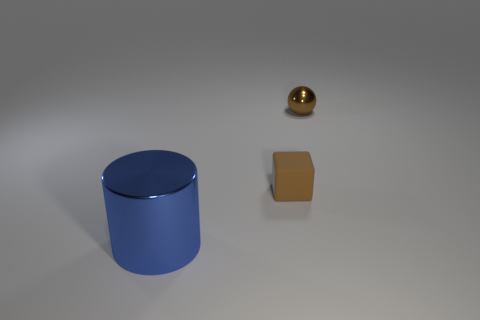Add 3 blue metal things. How many objects exist? 6 Subtract 1 cubes. How many cubes are left? 0 Subtract all cubes. How many objects are left? 2 Subtract all tiny yellow shiny blocks. Subtract all large blue shiny cylinders. How many objects are left? 2 Add 3 small brown cubes. How many small brown cubes are left? 4 Add 3 tiny gray metallic blocks. How many tiny gray metallic blocks exist? 3 Subtract 0 purple balls. How many objects are left? 3 Subtract all brown cylinders. Subtract all blue balls. How many cylinders are left? 1 Subtract all yellow spheres. How many green cylinders are left? 0 